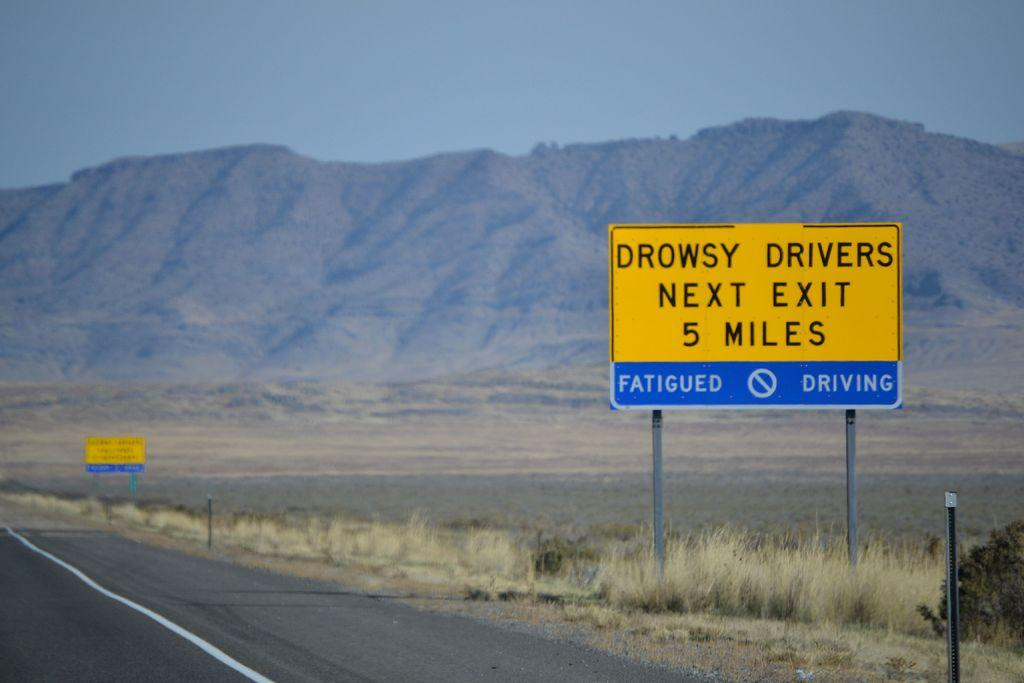<image>
Give a short and clear explanation of the subsequent image. A road with two yellow signs one of wish reads next exit on it. 